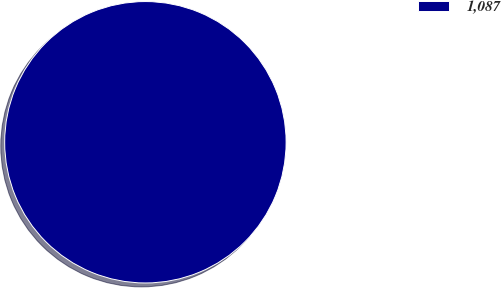<chart> <loc_0><loc_0><loc_500><loc_500><pie_chart><fcel>1,087<nl><fcel>100.0%<nl></chart> 